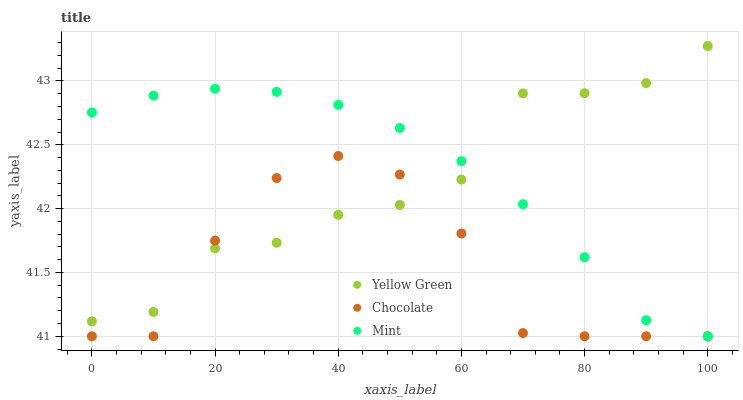Does Chocolate have the minimum area under the curve?
Answer yes or no. Yes. Does Mint have the maximum area under the curve?
Answer yes or no. Yes. Does Yellow Green have the minimum area under the curve?
Answer yes or no. No. Does Yellow Green have the maximum area under the curve?
Answer yes or no. No. Is Mint the smoothest?
Answer yes or no. Yes. Is Chocolate the roughest?
Answer yes or no. Yes. Is Yellow Green the smoothest?
Answer yes or no. No. Is Yellow Green the roughest?
Answer yes or no. No. Does Mint have the lowest value?
Answer yes or no. Yes. Does Yellow Green have the lowest value?
Answer yes or no. No. Does Yellow Green have the highest value?
Answer yes or no. Yes. Does Chocolate have the highest value?
Answer yes or no. No. Does Chocolate intersect Yellow Green?
Answer yes or no. Yes. Is Chocolate less than Yellow Green?
Answer yes or no. No. Is Chocolate greater than Yellow Green?
Answer yes or no. No. 